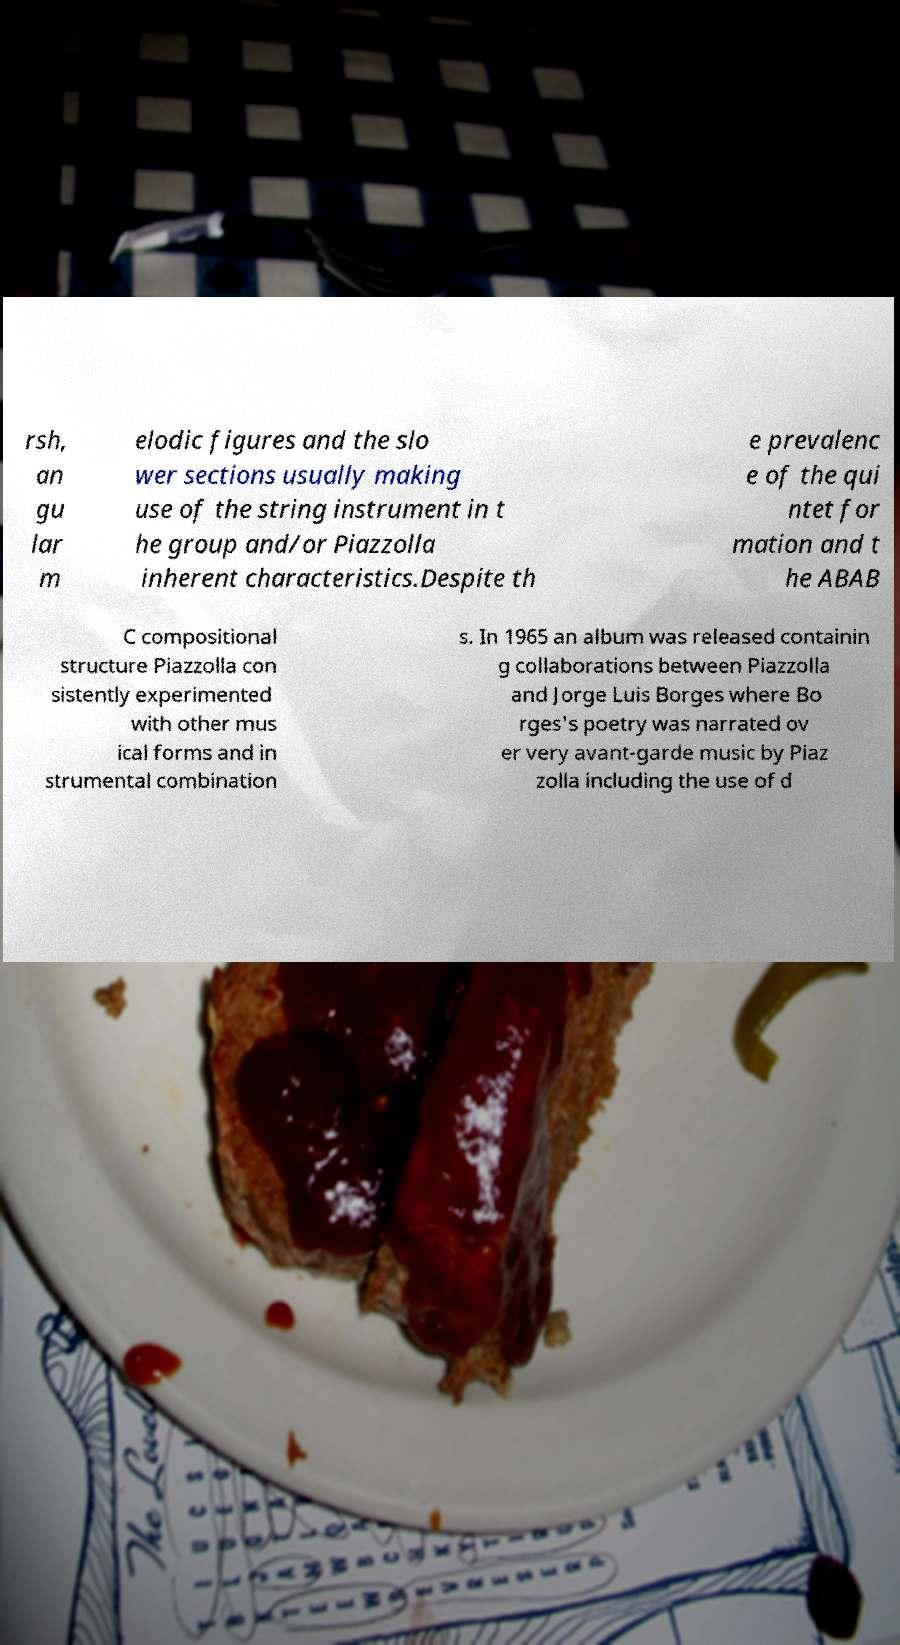Can you accurately transcribe the text from the provided image for me? rsh, an gu lar m elodic figures and the slo wer sections usually making use of the string instrument in t he group and/or Piazzolla inherent characteristics.Despite th e prevalenc e of the qui ntet for mation and t he ABAB C compositional structure Piazzolla con sistently experimented with other mus ical forms and in strumental combination s. In 1965 an album was released containin g collaborations between Piazzolla and Jorge Luis Borges where Bo rges's poetry was narrated ov er very avant-garde music by Piaz zolla including the use of d 